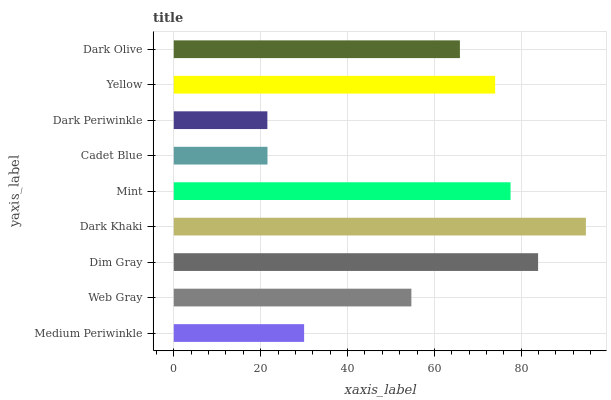Is Dark Periwinkle the minimum?
Answer yes or no. Yes. Is Dark Khaki the maximum?
Answer yes or no. Yes. Is Web Gray the minimum?
Answer yes or no. No. Is Web Gray the maximum?
Answer yes or no. No. Is Web Gray greater than Medium Periwinkle?
Answer yes or no. Yes. Is Medium Periwinkle less than Web Gray?
Answer yes or no. Yes. Is Medium Periwinkle greater than Web Gray?
Answer yes or no. No. Is Web Gray less than Medium Periwinkle?
Answer yes or no. No. Is Dark Olive the high median?
Answer yes or no. Yes. Is Dark Olive the low median?
Answer yes or no. Yes. Is Dark Khaki the high median?
Answer yes or no. No. Is Dim Gray the low median?
Answer yes or no. No. 